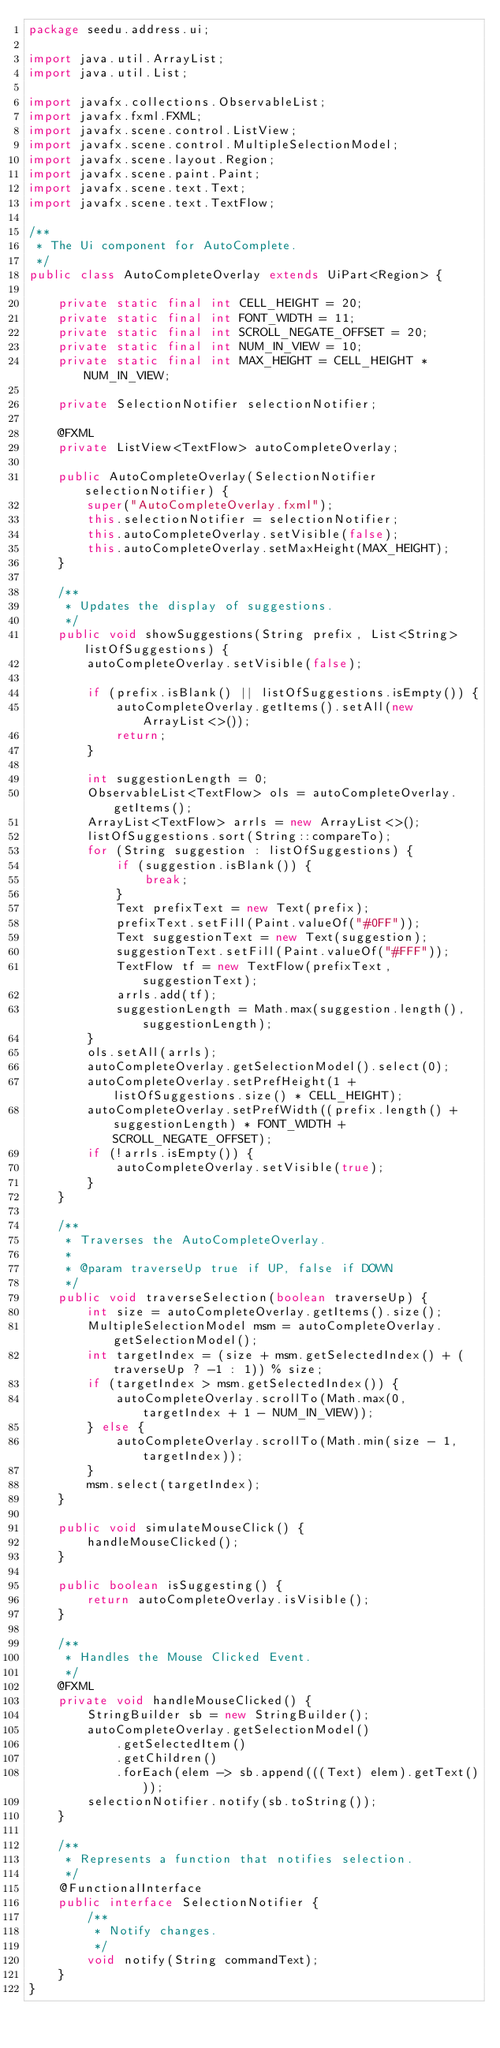Convert code to text. <code><loc_0><loc_0><loc_500><loc_500><_Java_>package seedu.address.ui;

import java.util.ArrayList;
import java.util.List;

import javafx.collections.ObservableList;
import javafx.fxml.FXML;
import javafx.scene.control.ListView;
import javafx.scene.control.MultipleSelectionModel;
import javafx.scene.layout.Region;
import javafx.scene.paint.Paint;
import javafx.scene.text.Text;
import javafx.scene.text.TextFlow;

/**
 * The Ui component for AutoComplete.
 */
public class AutoCompleteOverlay extends UiPart<Region> {

    private static final int CELL_HEIGHT = 20;
    private static final int FONT_WIDTH = 11;
    private static final int SCROLL_NEGATE_OFFSET = 20;
    private static final int NUM_IN_VIEW = 10;
    private static final int MAX_HEIGHT = CELL_HEIGHT * NUM_IN_VIEW;

    private SelectionNotifier selectionNotifier;

    @FXML
    private ListView<TextFlow> autoCompleteOverlay;

    public AutoCompleteOverlay(SelectionNotifier selectionNotifier) {
        super("AutoCompleteOverlay.fxml");
        this.selectionNotifier = selectionNotifier;
        this.autoCompleteOverlay.setVisible(false);
        this.autoCompleteOverlay.setMaxHeight(MAX_HEIGHT);
    }

    /**
     * Updates the display of suggestions.
     */
    public void showSuggestions(String prefix, List<String> listOfSuggestions) {
        autoCompleteOverlay.setVisible(false);

        if (prefix.isBlank() || listOfSuggestions.isEmpty()) {
            autoCompleteOverlay.getItems().setAll(new ArrayList<>());
            return;
        }

        int suggestionLength = 0;
        ObservableList<TextFlow> ols = autoCompleteOverlay.getItems();
        ArrayList<TextFlow> arrls = new ArrayList<>();
        listOfSuggestions.sort(String::compareTo);
        for (String suggestion : listOfSuggestions) {
            if (suggestion.isBlank()) {
                break;
            }
            Text prefixText = new Text(prefix);
            prefixText.setFill(Paint.valueOf("#0FF"));
            Text suggestionText = new Text(suggestion);
            suggestionText.setFill(Paint.valueOf("#FFF"));
            TextFlow tf = new TextFlow(prefixText, suggestionText);
            arrls.add(tf);
            suggestionLength = Math.max(suggestion.length(), suggestionLength);
        }
        ols.setAll(arrls);
        autoCompleteOverlay.getSelectionModel().select(0);
        autoCompleteOverlay.setPrefHeight(1 + listOfSuggestions.size() * CELL_HEIGHT);
        autoCompleteOverlay.setPrefWidth((prefix.length() + suggestionLength) * FONT_WIDTH + SCROLL_NEGATE_OFFSET);
        if (!arrls.isEmpty()) {
            autoCompleteOverlay.setVisible(true);
        }
    }

    /**
     * Traverses the AutoCompleteOverlay.
     *
     * @param traverseUp true if UP, false if DOWN
     */
    public void traverseSelection(boolean traverseUp) {
        int size = autoCompleteOverlay.getItems().size();
        MultipleSelectionModel msm = autoCompleteOverlay.getSelectionModel();
        int targetIndex = (size + msm.getSelectedIndex() + (traverseUp ? -1 : 1)) % size;
        if (targetIndex > msm.getSelectedIndex()) {
            autoCompleteOverlay.scrollTo(Math.max(0, targetIndex + 1 - NUM_IN_VIEW));
        } else {
            autoCompleteOverlay.scrollTo(Math.min(size - 1, targetIndex));
        }
        msm.select(targetIndex);
    }

    public void simulateMouseClick() {
        handleMouseClicked();
    }

    public boolean isSuggesting() {
        return autoCompleteOverlay.isVisible();
    }

    /**
     * Handles the Mouse Clicked Event.
     */
    @FXML
    private void handleMouseClicked() {
        StringBuilder sb = new StringBuilder();
        autoCompleteOverlay.getSelectionModel()
            .getSelectedItem()
            .getChildren()
            .forEach(elem -> sb.append(((Text) elem).getText()));
        selectionNotifier.notify(sb.toString());
    }

    /**
     * Represents a function that notifies selection.
     */
    @FunctionalInterface
    public interface SelectionNotifier {
        /**
         * Notify changes.
         */
        void notify(String commandText);
    }
}
</code> 